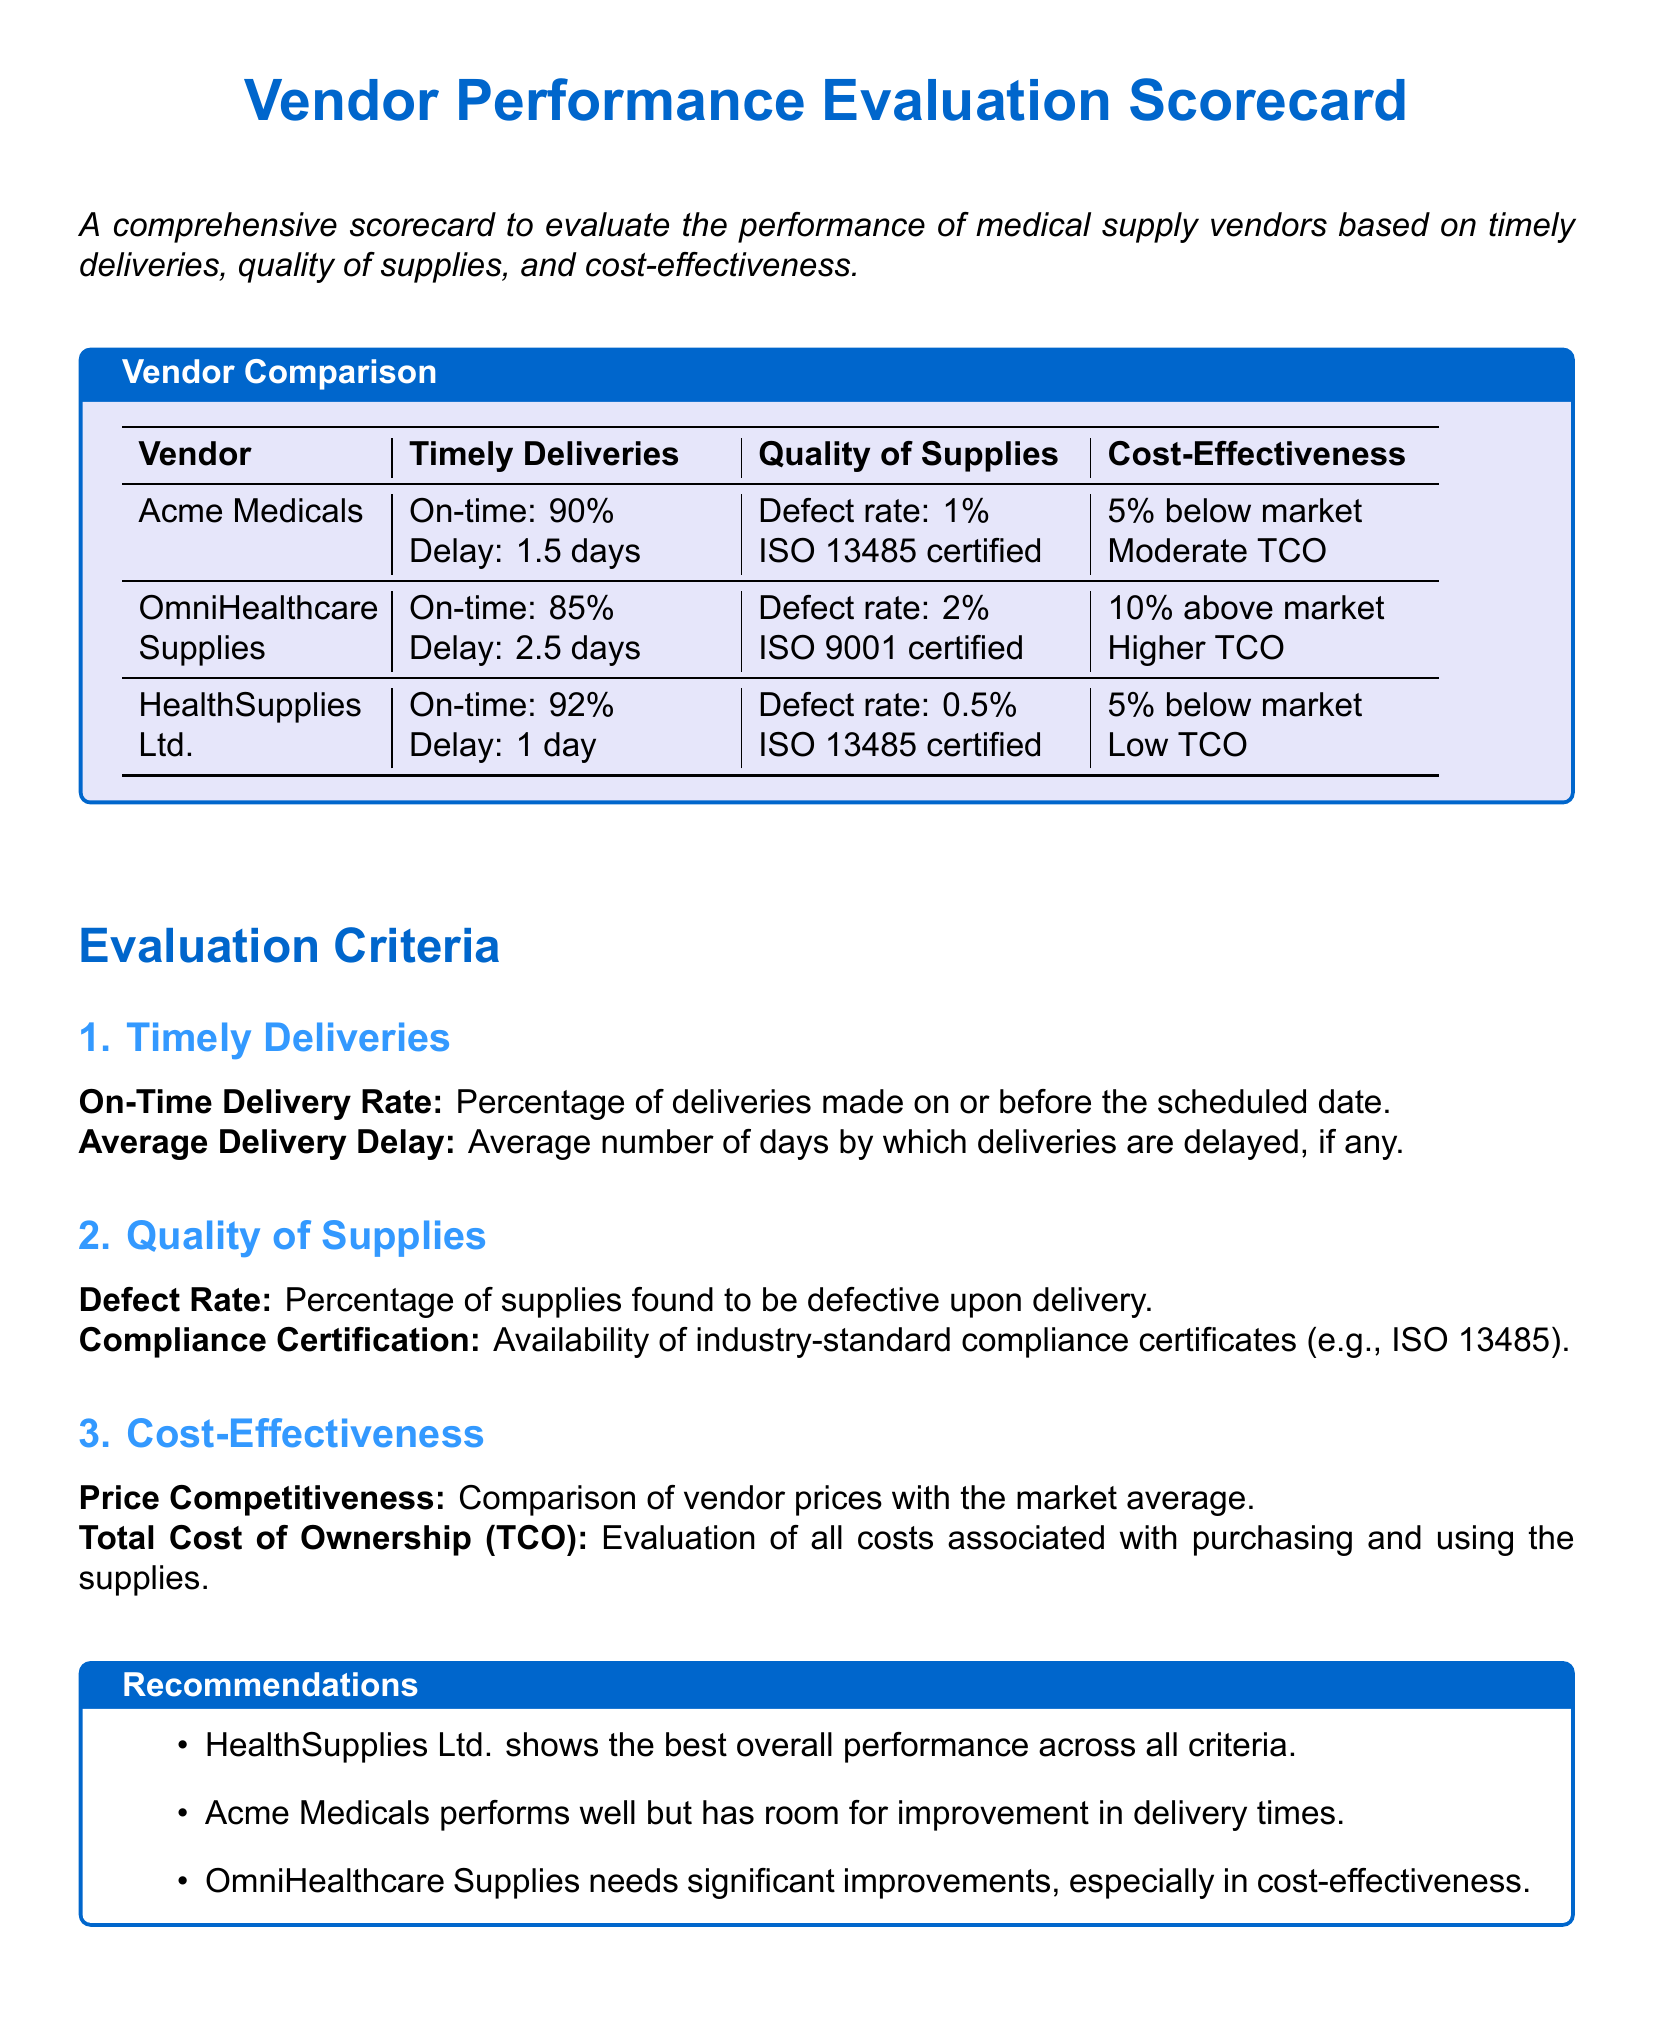What is the on-time delivery rate for Acme Medicals? The on-time delivery rate for Acme Medicals is stated as 90%.
Answer: 90% What is the defect rate for HealthSupplies Ltd.? The document specifies that the defect rate for HealthSupplies Ltd. is 0.5%.
Answer: 0.5% Which vendor has the highest on-time delivery rate? The evaluation indicates that HealthSupplies Ltd. has the highest on-time delivery rate of 92%.
Answer: HealthSupplies Ltd What is the average delivery delay for OmniHealthcare Supplies? The average delivery delay for OmniHealthcare Supplies is noted as 2.5 days.
Answer: 2.5 days How does Acme Medicals' cost-effectiveness compare to the market? The document mentions that Acme Medicals is 5% below market.
Answer: 5% below market Which vendor has an ISO certification? Both Acme Medicals and HealthSupplies Ltd. are noted to be ISO certified.
Answer: Acme Medicals, HealthSupplies Ltd What is the total cost of ownership for OmniHealthcare Supplies? The document states that OmniHealthcare Supplies has a higher TCO.
Answer: Higher TCO What recommendation is made regarding OmniHealthcare Supplies? The recommendation indicates that OmniHealthcare Supplies needs significant improvements, especially in cost-effectiveness.
Answer: Significant improvements What is the quality certification for Acme Medicals? The quality certification for Acme Medicals is ISO 13485 certified.
Answer: ISO 13485 certified 